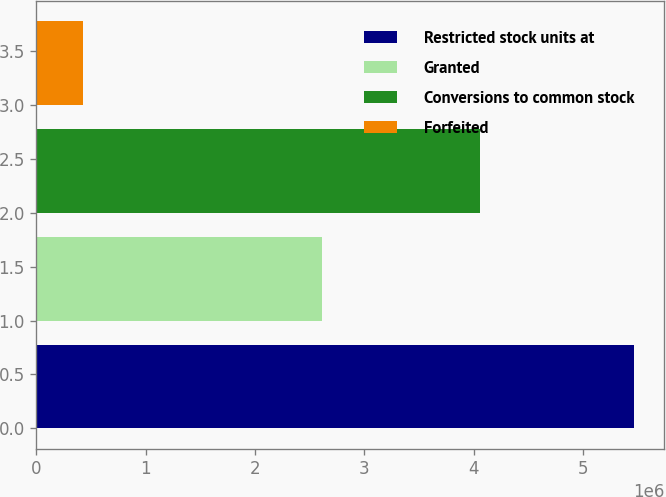Convert chart. <chart><loc_0><loc_0><loc_500><loc_500><bar_chart><fcel>Restricted stock units at<fcel>Granted<fcel>Conversions to common stock<fcel>Forfeited<nl><fcel>5.47122e+06<fcel>2.61318e+06<fcel>4.05687e+06<fcel>430677<nl></chart> 